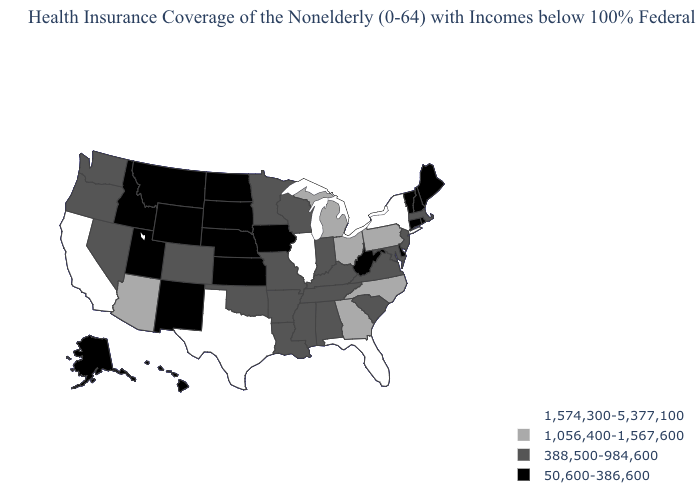Among the states that border New Jersey , does Pennsylvania have the highest value?
Give a very brief answer. No. Name the states that have a value in the range 1,574,300-5,377,100?
Be succinct. California, Florida, Illinois, New York, Texas. What is the value of Indiana?
Concise answer only. 388,500-984,600. What is the value of Virginia?
Answer briefly. 388,500-984,600. What is the value of New Hampshire?
Write a very short answer. 50,600-386,600. Among the states that border North Carolina , which have the lowest value?
Answer briefly. South Carolina, Tennessee, Virginia. What is the value of Alabama?
Answer briefly. 388,500-984,600. Name the states that have a value in the range 1,056,400-1,567,600?
Write a very short answer. Arizona, Georgia, Michigan, North Carolina, Ohio, Pennsylvania. Name the states that have a value in the range 388,500-984,600?
Short answer required. Alabama, Arkansas, Colorado, Indiana, Kentucky, Louisiana, Maryland, Massachusetts, Minnesota, Mississippi, Missouri, Nevada, New Jersey, Oklahoma, Oregon, South Carolina, Tennessee, Virginia, Washington, Wisconsin. Does Oregon have the lowest value in the USA?
Give a very brief answer. No. Does Utah have the same value as Connecticut?
Concise answer only. Yes. Name the states that have a value in the range 1,056,400-1,567,600?
Short answer required. Arizona, Georgia, Michigan, North Carolina, Ohio, Pennsylvania. Does Michigan have the lowest value in the USA?
Keep it brief. No. Name the states that have a value in the range 388,500-984,600?
Keep it brief. Alabama, Arkansas, Colorado, Indiana, Kentucky, Louisiana, Maryland, Massachusetts, Minnesota, Mississippi, Missouri, Nevada, New Jersey, Oklahoma, Oregon, South Carolina, Tennessee, Virginia, Washington, Wisconsin. 